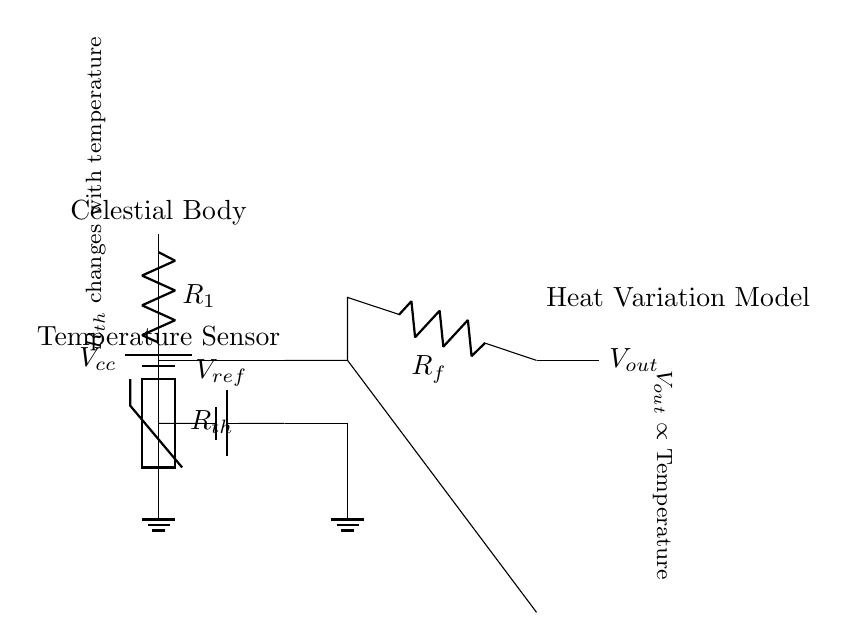What component measures temperature? The thermistor, labeled as R_th in the circuit, changes resistance based on temperature, allowing it to measure temperature variations.
Answer: R_th What does V_out represent? V_out is the output voltage of the op-amp, which corresponds to the temperature being modeled. It is proportional to the voltage difference created by the thermistor and reference voltage.
Answer: Temperature How do you increase V_out? To increase V_out, you can increase the temperature of the thermistor, which will lower its resistance, causing a greater voltage drop across it in the voltage divider arrangement.
Answer: Increase temperature What is the function of the op-amp? The op-amp amplifies the difference between the voltages at its positive and negative inputs, enabling the circuit to respond effectively to changes in temperature sensed by the thermistor.
Answer: Amplification What is the role of R_f in the circuit? R_f, the feedback resistor, determines the gain of the op-amp, setting how much the input signal (from the thermistor) is amplified to produce V_out.
Answer: Gain control What is the relationship between R_th and temperature? The resistance R_th of the thermistor decreases as the temperature increases, establishing an inverse relationship. This enables the thermistor to effectively track temperature variations.
Answer: Inverse relationship 